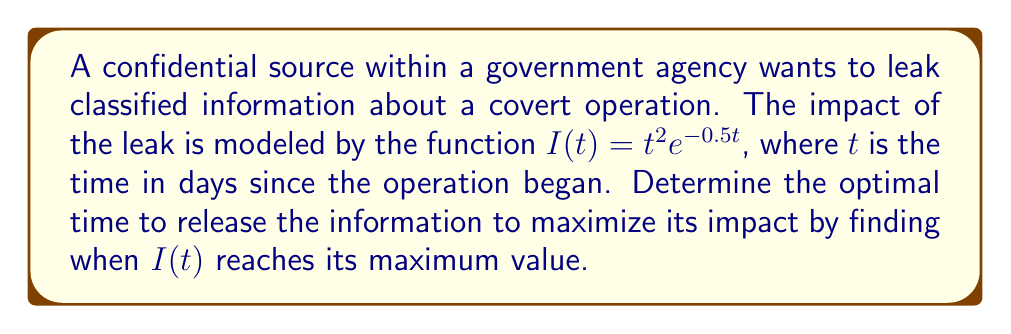Can you answer this question? To find the maximum value of $I(t)$, we need to find where its derivative equals zero:

1) First, let's calculate the derivative of $I(t)$ using the product rule:
   $$I'(t) = (t^2)'e^{-0.5t} + t^2(e^{-0.5t})'$$
   $$I'(t) = 2te^{-0.5t} + t^2(-0.5e^{-0.5t})$$
   $$I'(t) = e^{-0.5t}(2t - 0.5t^2)$$

2) Set $I'(t) = 0$ and solve for $t$:
   $$e^{-0.5t}(2t - 0.5t^2) = 0$$
   
   Since $e^{-0.5t}$ is never zero, we solve:
   $$2t - 0.5t^2 = 0$$
   $$t(2 - 0.5t) = 0$$
   
   This gives us $t = 0$ or $t = 4$

3) $t = 0$ corresponds to a minimum (the start of the operation), so the maximum occurs at $t = 4$ days.

4) To verify, we can check the second derivative is negative at $t = 4$:
   $$I''(t) = e^{-0.5t}(2 - 2t + 0.25t^2)$$
   $$I''(4) = e^{-2}(2 - 8 + 4) = -2e^{-2} < 0$$

Therefore, the optimal time to release the information is 4 days after the operation began.
Answer: 4 days 